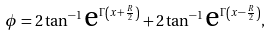<formula> <loc_0><loc_0><loc_500><loc_500>\phi = 2 \tan ^ { - 1 } \text {e} ^ { \Gamma \left ( x + \frac { R } { 2 } \right ) } + 2 \tan ^ { - 1 } \text {e} ^ { \Gamma \left ( x - \frac { R } { 2 } \right ) } ,</formula> 